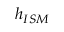<formula> <loc_0><loc_0><loc_500><loc_500>h _ { I S M }</formula> 